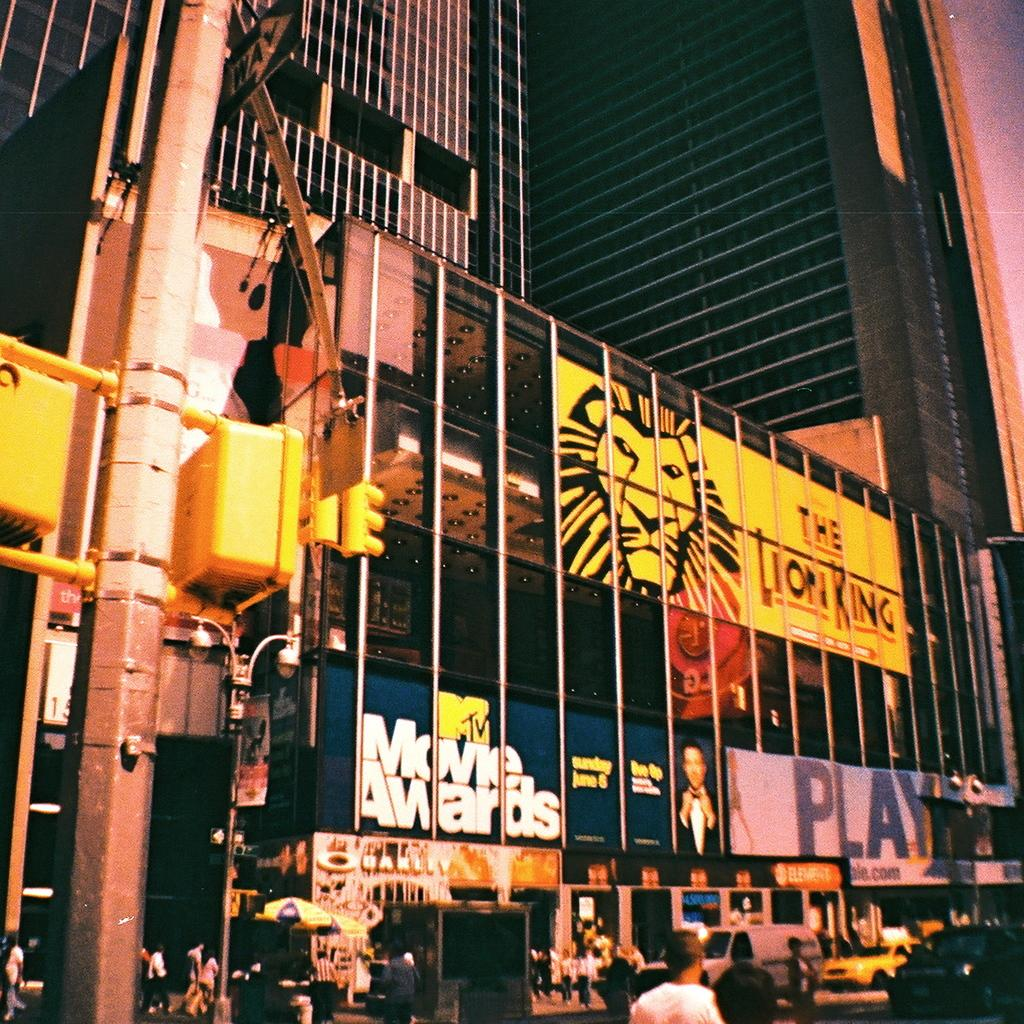Provide a one-sentence caption for the provided image. Huge building outside advertising upcoming events especially the Lion King. 